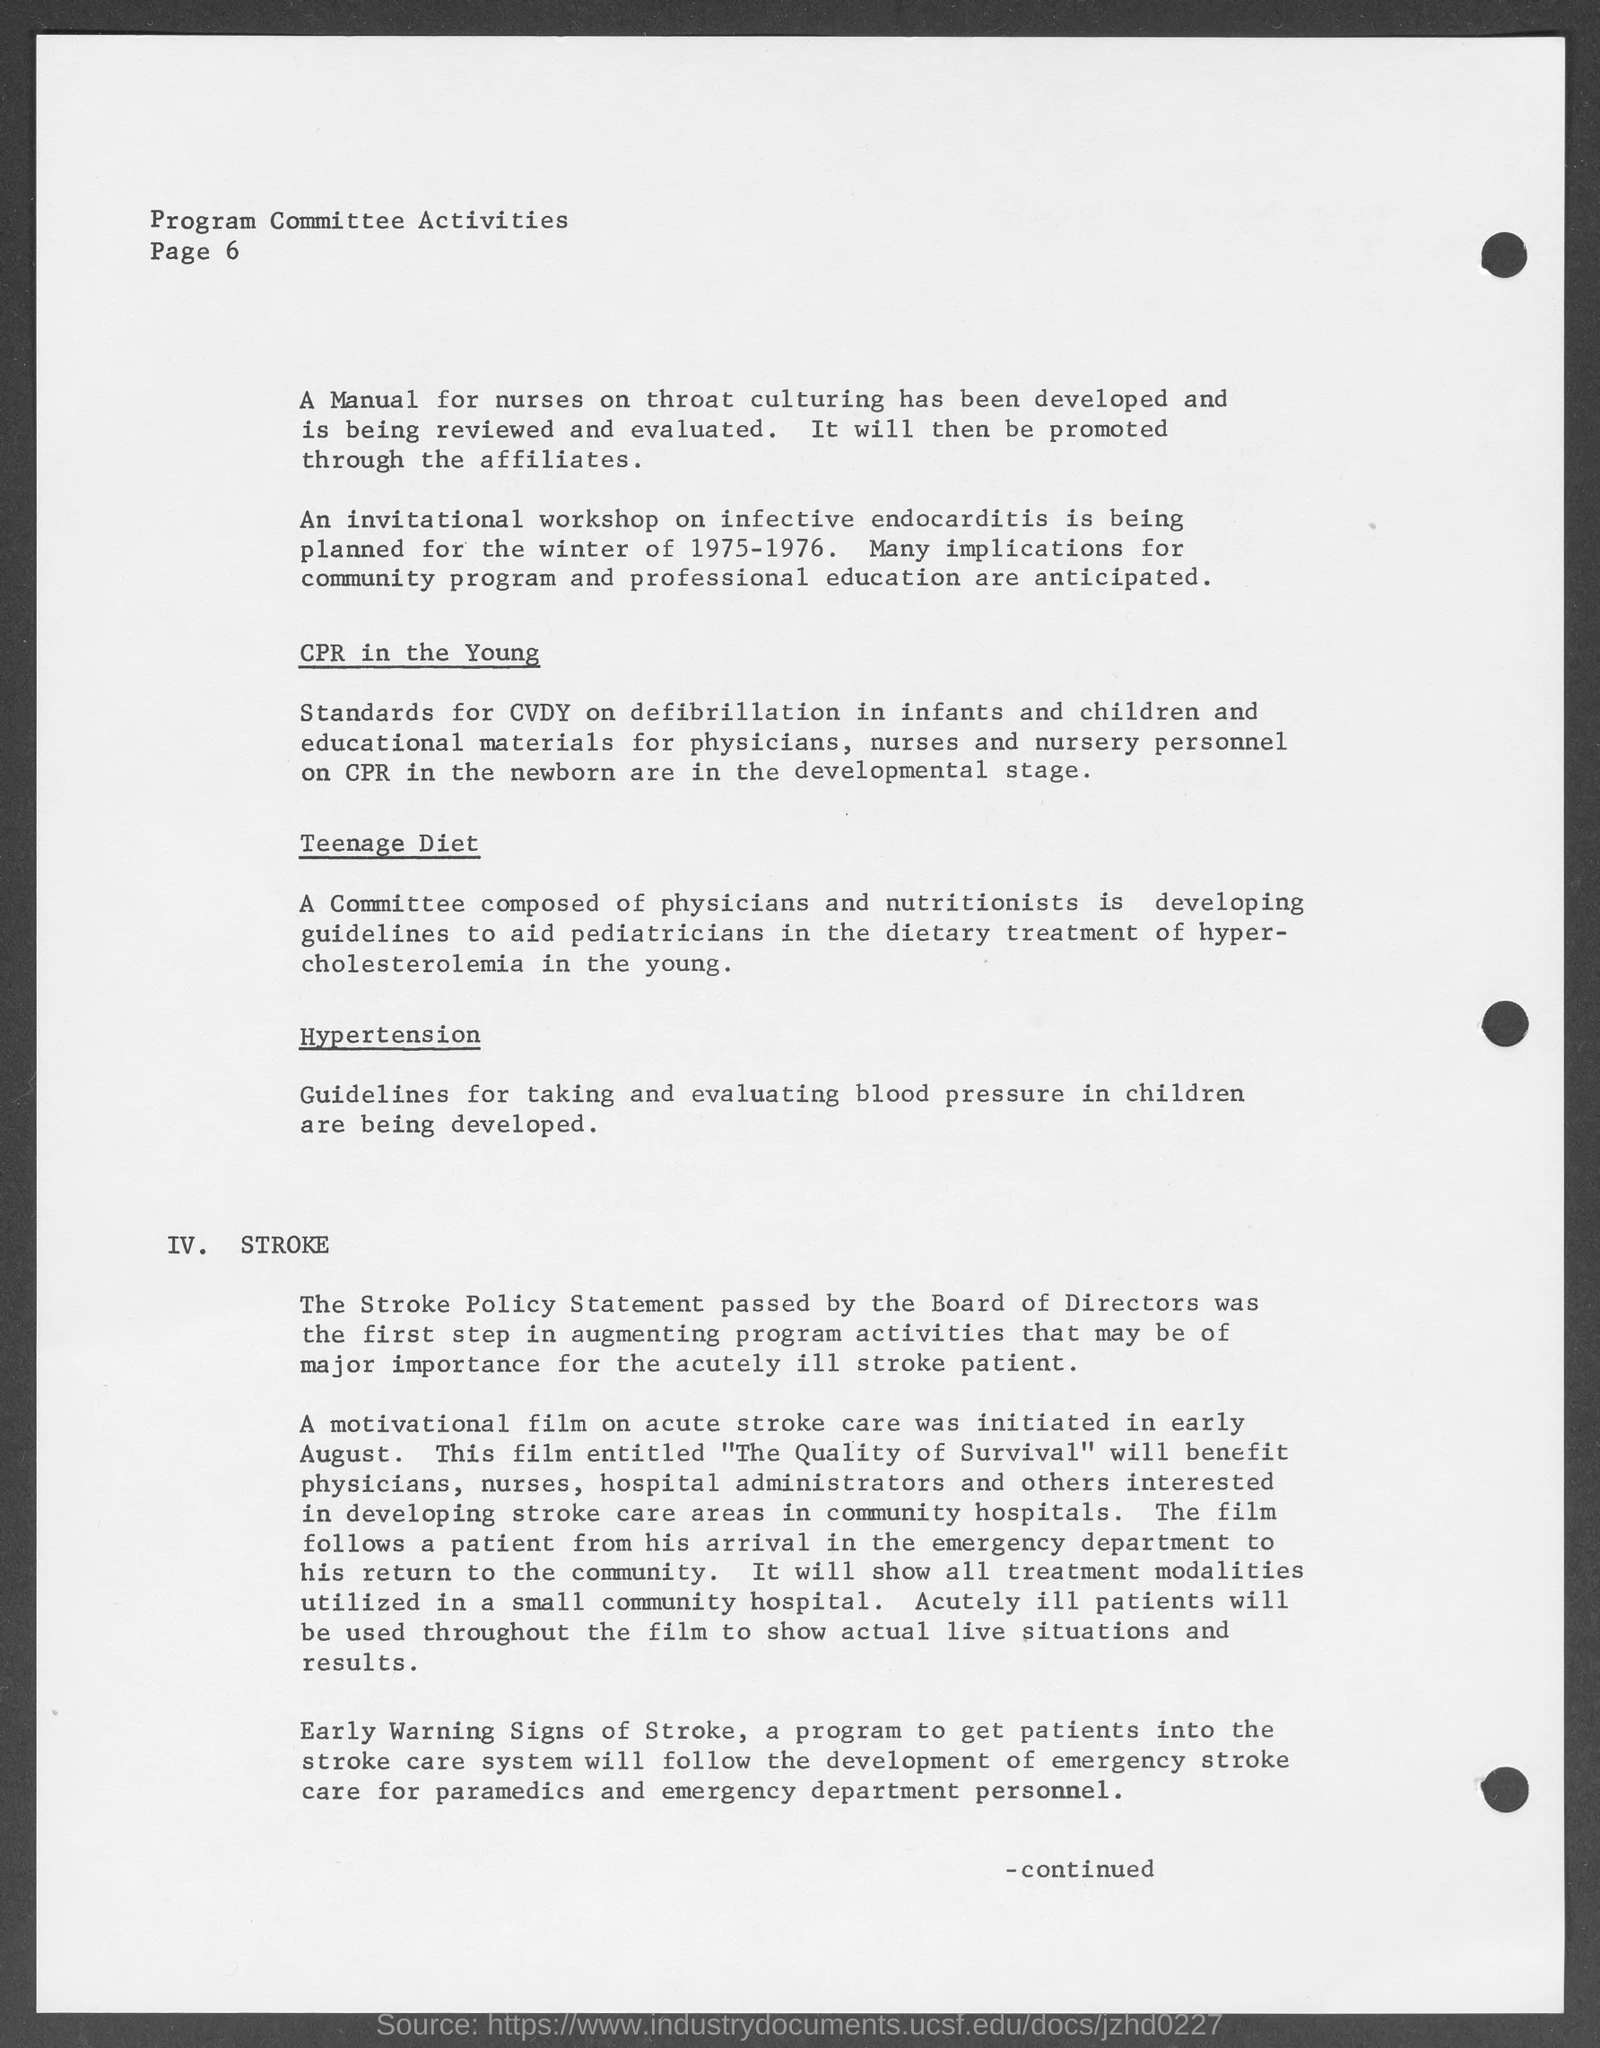What is the page number mentioned in the document ?
Keep it short and to the point. 6. What is written on top of page number at top left corner?
Your answer should be very brief. Program committee activities. An invitational workshop on infective endocarditis is being planned for which year?
Keep it short and to the point. 1975-1976. 